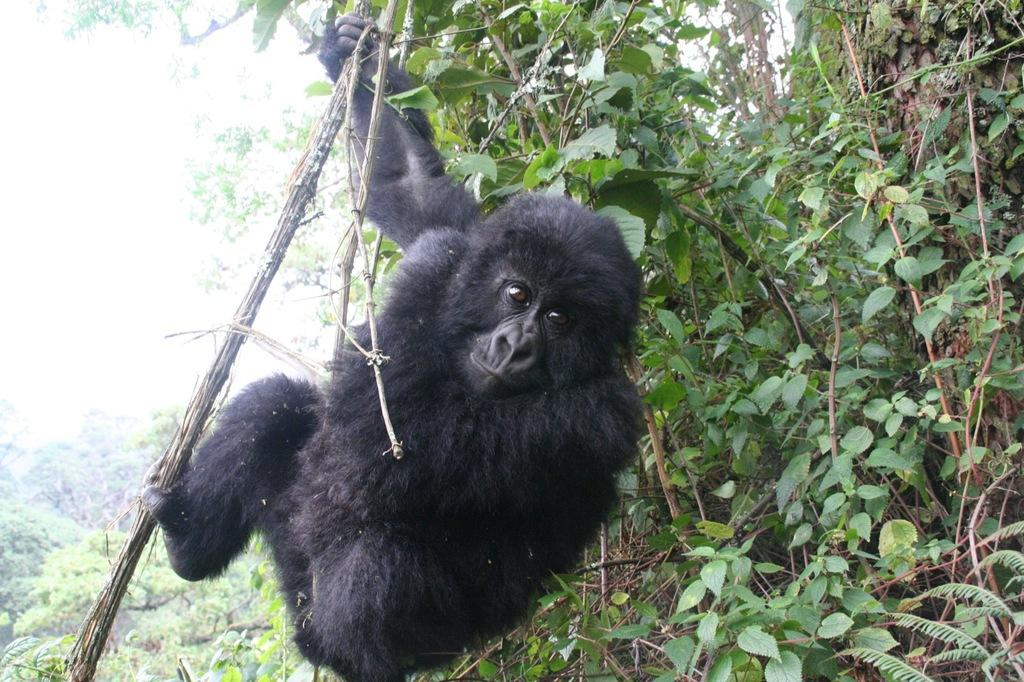What is the main subject of the image? There is an animal on a plant in the image. What can be seen on the right side of the image? There are plants on the right side of the image. What is visible in the background of the image? There are trees and the sky visible in the background of the image. Can you tell me how many feathers are on the fireman in the image? There is no fireman or feathers present in the image. How high does the animal jump in the image? The image does not show the animal jumping, so we cannot determine its jumping height. 